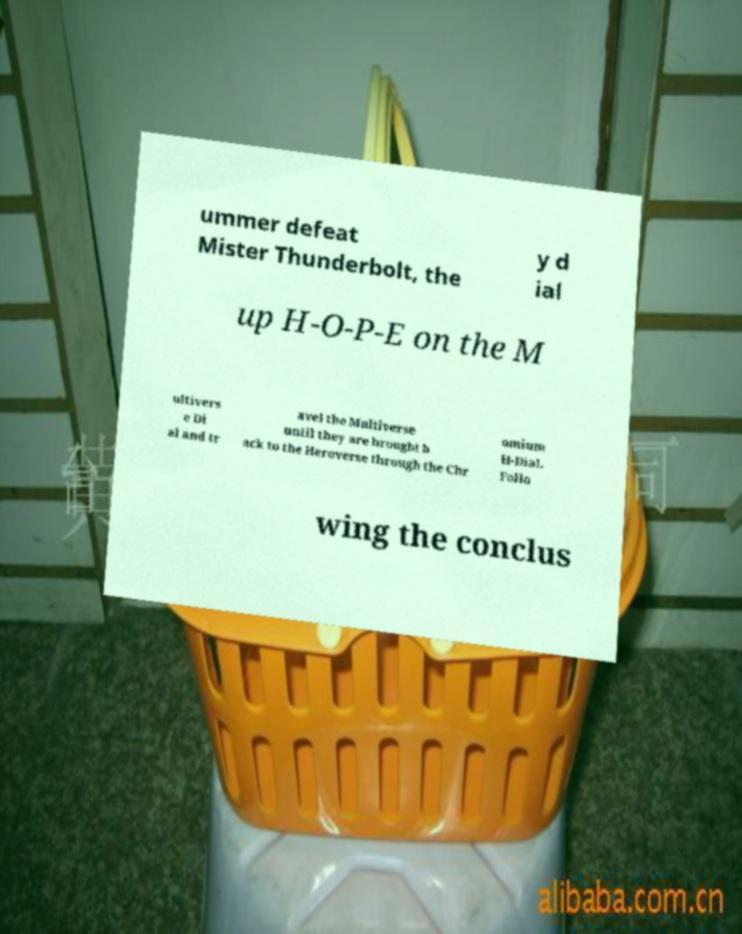I need the written content from this picture converted into text. Can you do that? ummer defeat Mister Thunderbolt, the y d ial up H-O-P-E on the M ultivers e Di al and tr avel the Multiverse until they are brought b ack to the Heroverse through the Chr omium H-Dial. Follo wing the conclus 